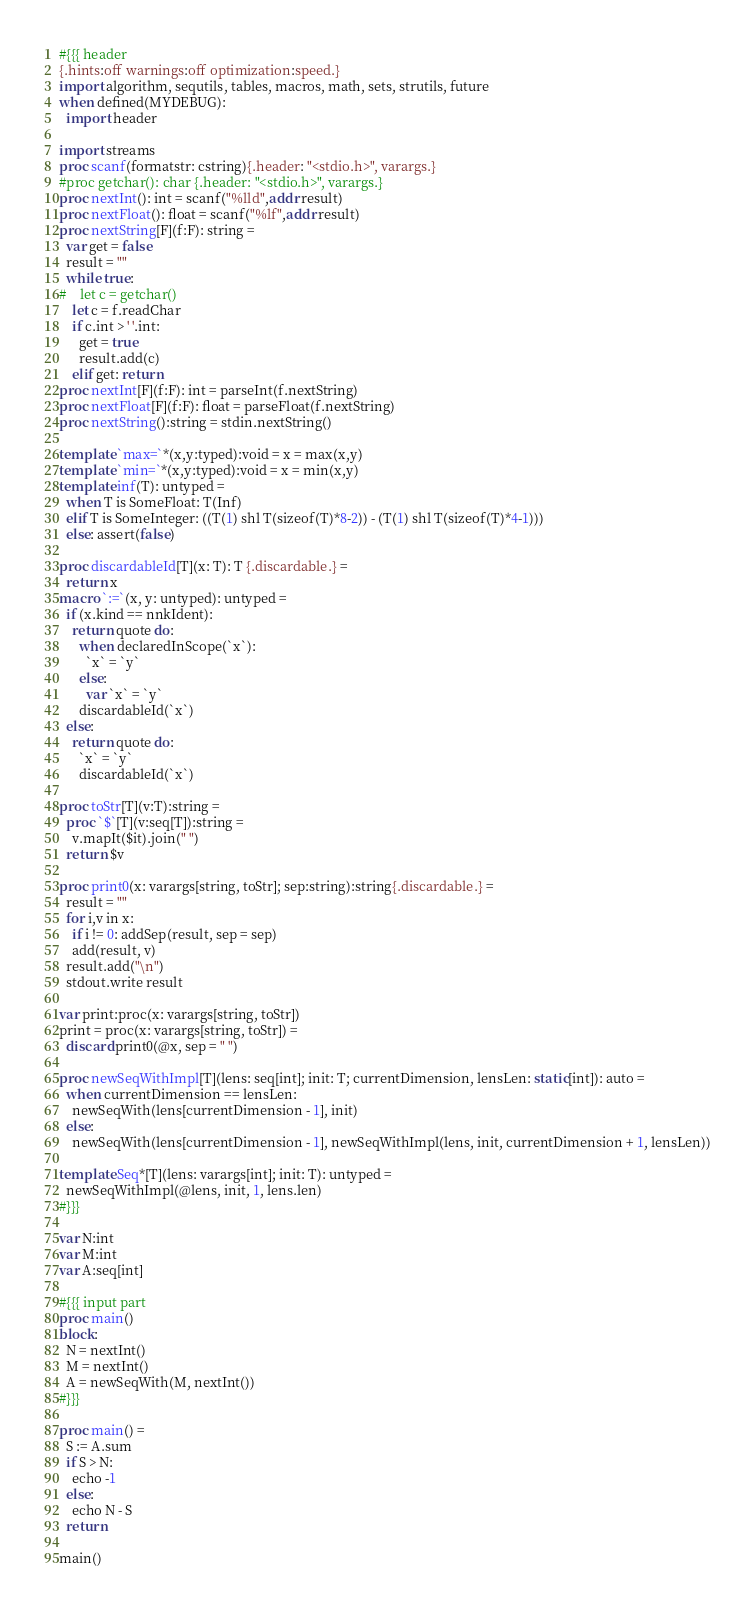<code> <loc_0><loc_0><loc_500><loc_500><_Nim_>#{{{ header
{.hints:off warnings:off optimization:speed.}
import algorithm, sequtils, tables, macros, math, sets, strutils, future
when defined(MYDEBUG):
  import header

import streams
proc scanf(formatstr: cstring){.header: "<stdio.h>", varargs.}
#proc getchar(): char {.header: "<stdio.h>", varargs.}
proc nextInt(): int = scanf("%lld",addr result)
proc nextFloat(): float = scanf("%lf",addr result)
proc nextString[F](f:F): string =
  var get = false
  result = ""
  while true:
#    let c = getchar()
    let c = f.readChar
    if c.int > ' '.int:
      get = true
      result.add(c)
    elif get: return
proc nextInt[F](f:F): int = parseInt(f.nextString)
proc nextFloat[F](f:F): float = parseFloat(f.nextString)
proc nextString():string = stdin.nextString()

template `max=`*(x,y:typed):void = x = max(x,y)
template `min=`*(x,y:typed):void = x = min(x,y)
template inf(T): untyped = 
  when T is SomeFloat: T(Inf)
  elif T is SomeInteger: ((T(1) shl T(sizeof(T)*8-2)) - (T(1) shl T(sizeof(T)*4-1)))
  else: assert(false)

proc discardableId[T](x: T): T {.discardable.} =
  return x
macro `:=`(x, y: untyped): untyped =
  if (x.kind == nnkIdent):
    return quote do:
      when declaredInScope(`x`):
        `x` = `y`
      else:
        var `x` = `y`
      discardableId(`x`)
  else:
    return quote do:
      `x` = `y`
      discardableId(`x`)

proc toStr[T](v:T):string =
  proc `$`[T](v:seq[T]):string =
    v.mapIt($it).join(" ")
  return $v

proc print0(x: varargs[string, toStr]; sep:string):string{.discardable.} =
  result = ""
  for i,v in x:
    if i != 0: addSep(result, sep = sep)
    add(result, v)
  result.add("\n")
  stdout.write result

var print:proc(x: varargs[string, toStr])
print = proc(x: varargs[string, toStr]) =
  discard print0(@x, sep = " ")

proc newSeqWithImpl[T](lens: seq[int]; init: T; currentDimension, lensLen: static[int]): auto =
  when currentDimension == lensLen:
    newSeqWith(lens[currentDimension - 1], init)
  else:
    newSeqWith(lens[currentDimension - 1], newSeqWithImpl(lens, init, currentDimension + 1, lensLen))

template Seq*[T](lens: varargs[int]; init: T): untyped =
  newSeqWithImpl(@lens, init, 1, lens.len)
#}}}

var N:int
var M:int
var A:seq[int]

#{{{ input part
proc main()
block:
  N = nextInt()
  M = nextInt()
  A = newSeqWith(M, nextInt())
#}}}

proc main() =
  S := A.sum
  if S > N:
    echo -1
  else:
    echo N - S
  return

main()
</code> 